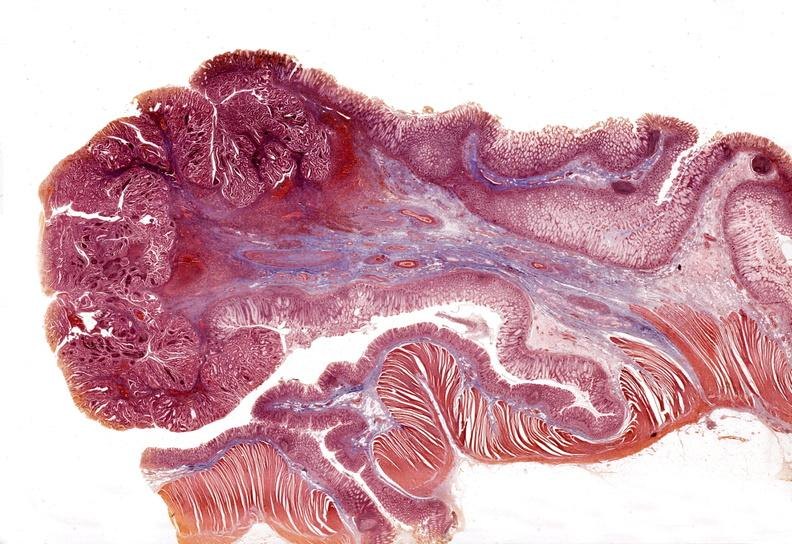s gastrointestinal present?
Answer the question using a single word or phrase. Yes 